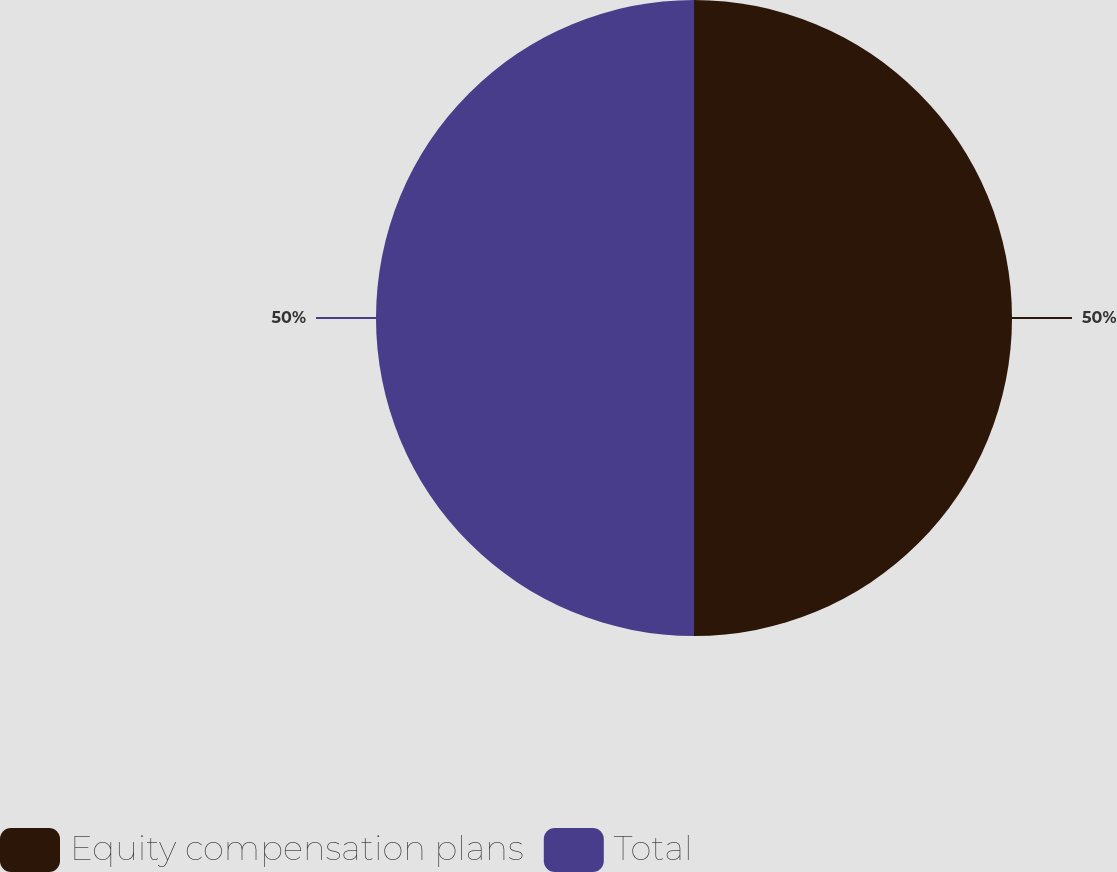Convert chart to OTSL. <chart><loc_0><loc_0><loc_500><loc_500><pie_chart><fcel>Equity compensation plans<fcel>Total<nl><fcel>50.0%<fcel>50.0%<nl></chart> 